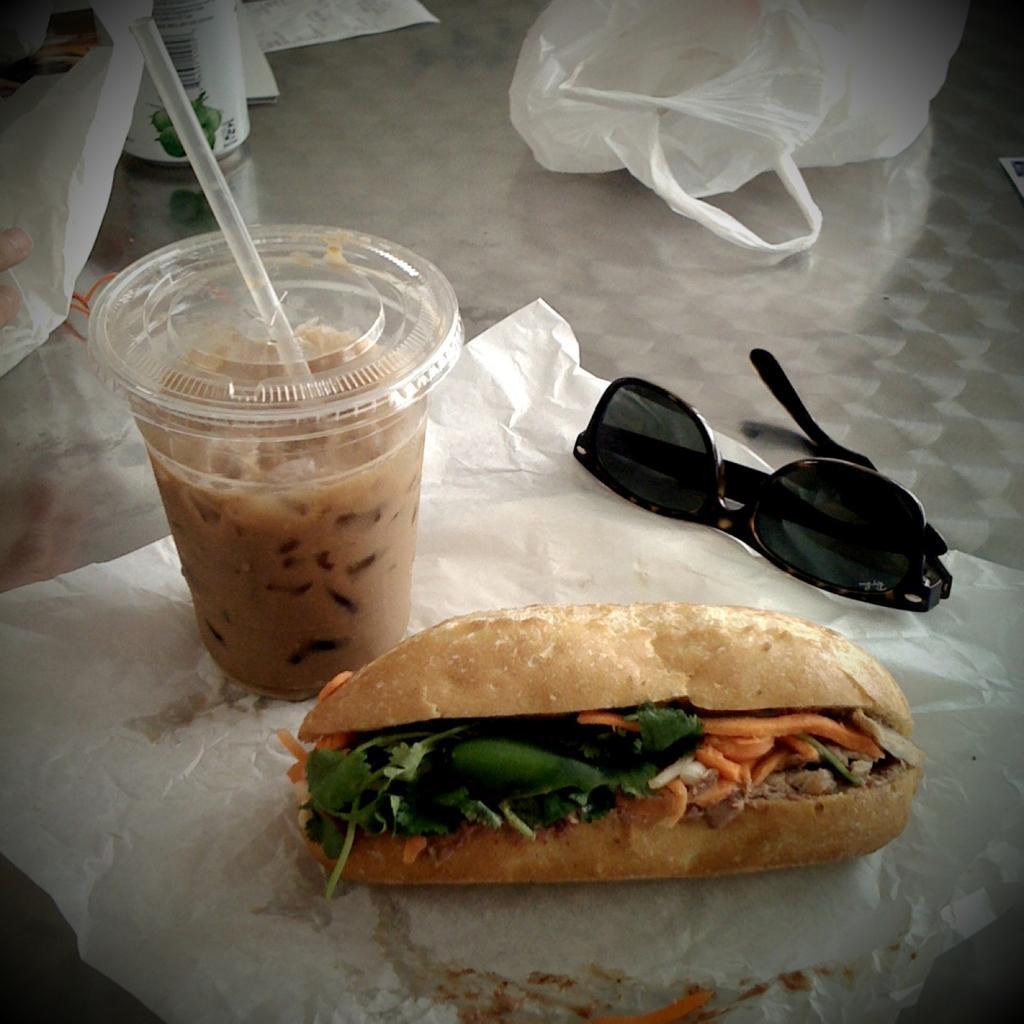Describe this image in one or two sentences. In the left side it's a drink in a glass and here it is a burger on a tissue paper. In the right side it is glasses. 